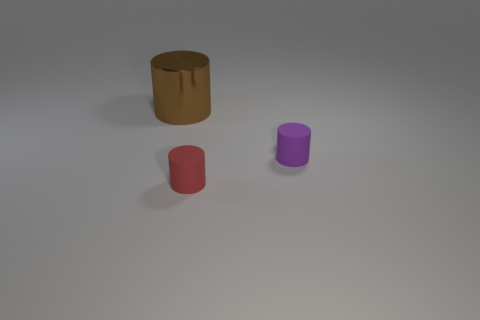Subtract all tiny rubber cylinders. How many cylinders are left? 1 Subtract 1 cylinders. How many cylinders are left? 2 Add 2 tiny yellow matte spheres. How many objects exist? 5 Add 1 small cyan cubes. How many small cyan cubes exist? 1 Subtract 1 purple cylinders. How many objects are left? 2 Subtract all green cylinders. Subtract all gray balls. How many cylinders are left? 3 Subtract all green matte things. Subtract all rubber objects. How many objects are left? 1 Add 2 tiny red things. How many tiny red things are left? 3 